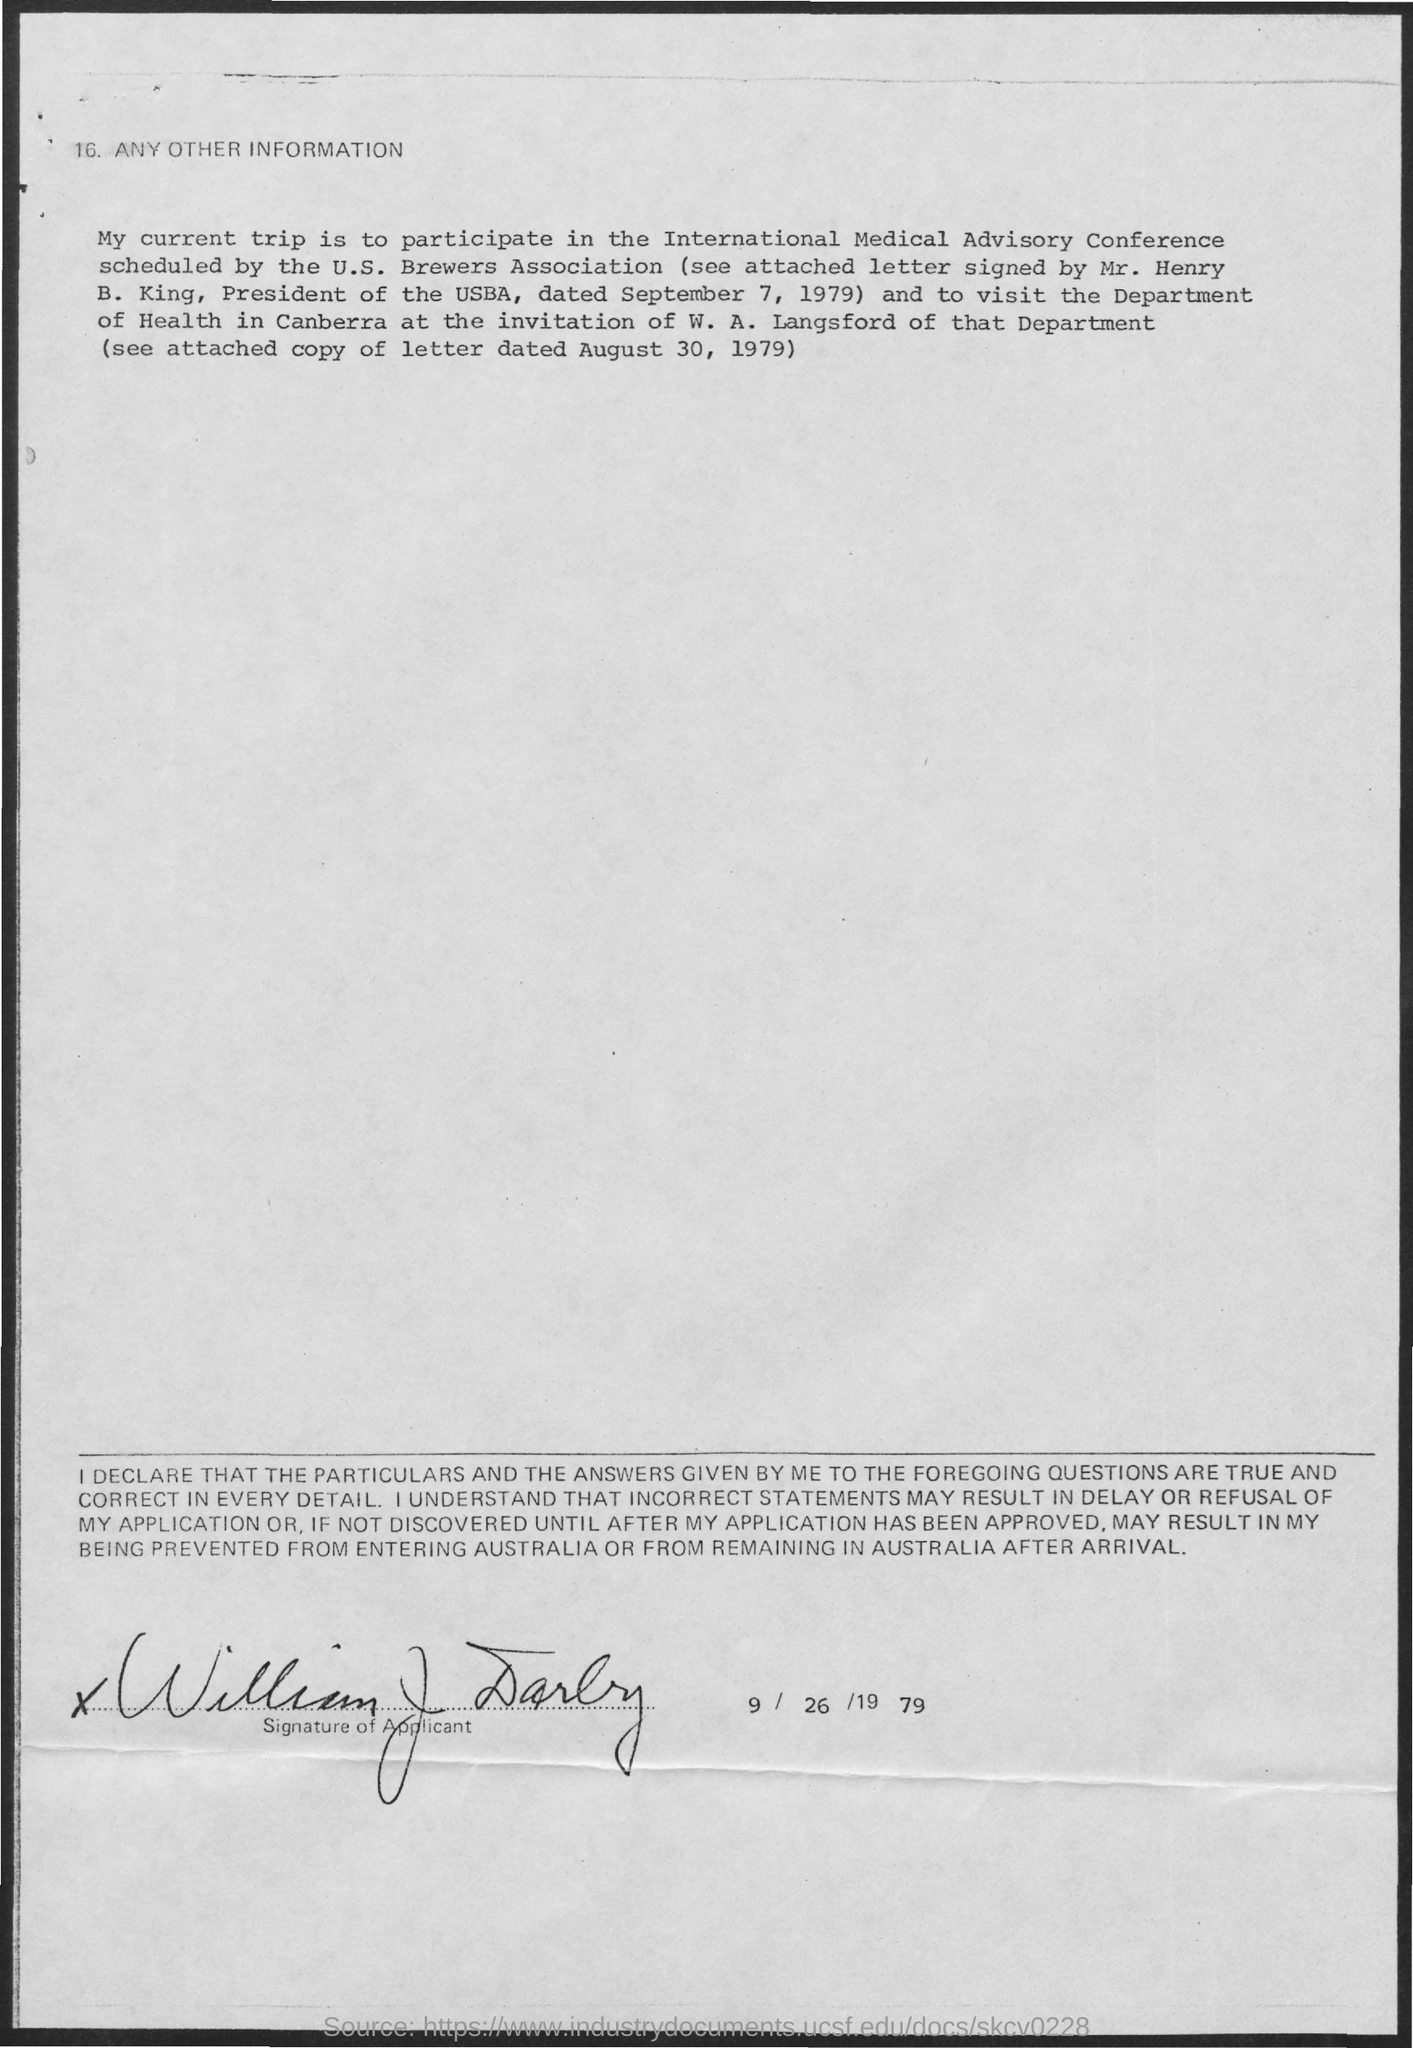Who has scheduled the international medical advisory conference?
Keep it short and to the point. U.S. Brewers Association. Who has signed the attached letter?
Your answer should be compact. Mr. Henry B. King. What is the designation of mr. henry?
Offer a terse response. President of the USBA. What is the attached letter signed by mr. henry  dated?
Keep it short and to the point. September 7, 1979. Which department w. a. langsford belong to?
Offer a terse response. Department of health. Where is department of health?
Your response must be concise. Canberra. What is the date on which the document was signed?
Your answer should be compact. 9/26/1979. 